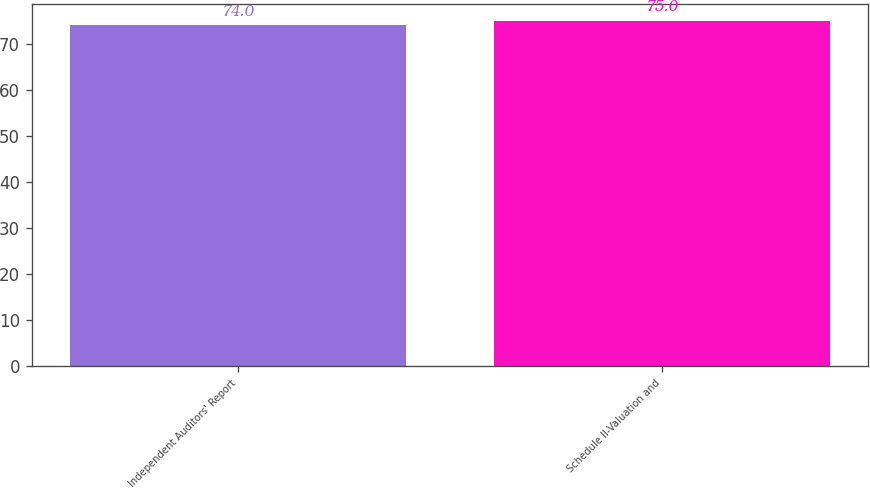Convert chart. <chart><loc_0><loc_0><loc_500><loc_500><bar_chart><fcel>Independent Auditors' Report<fcel>Schedule II-Valuation and<nl><fcel>74<fcel>75<nl></chart> 